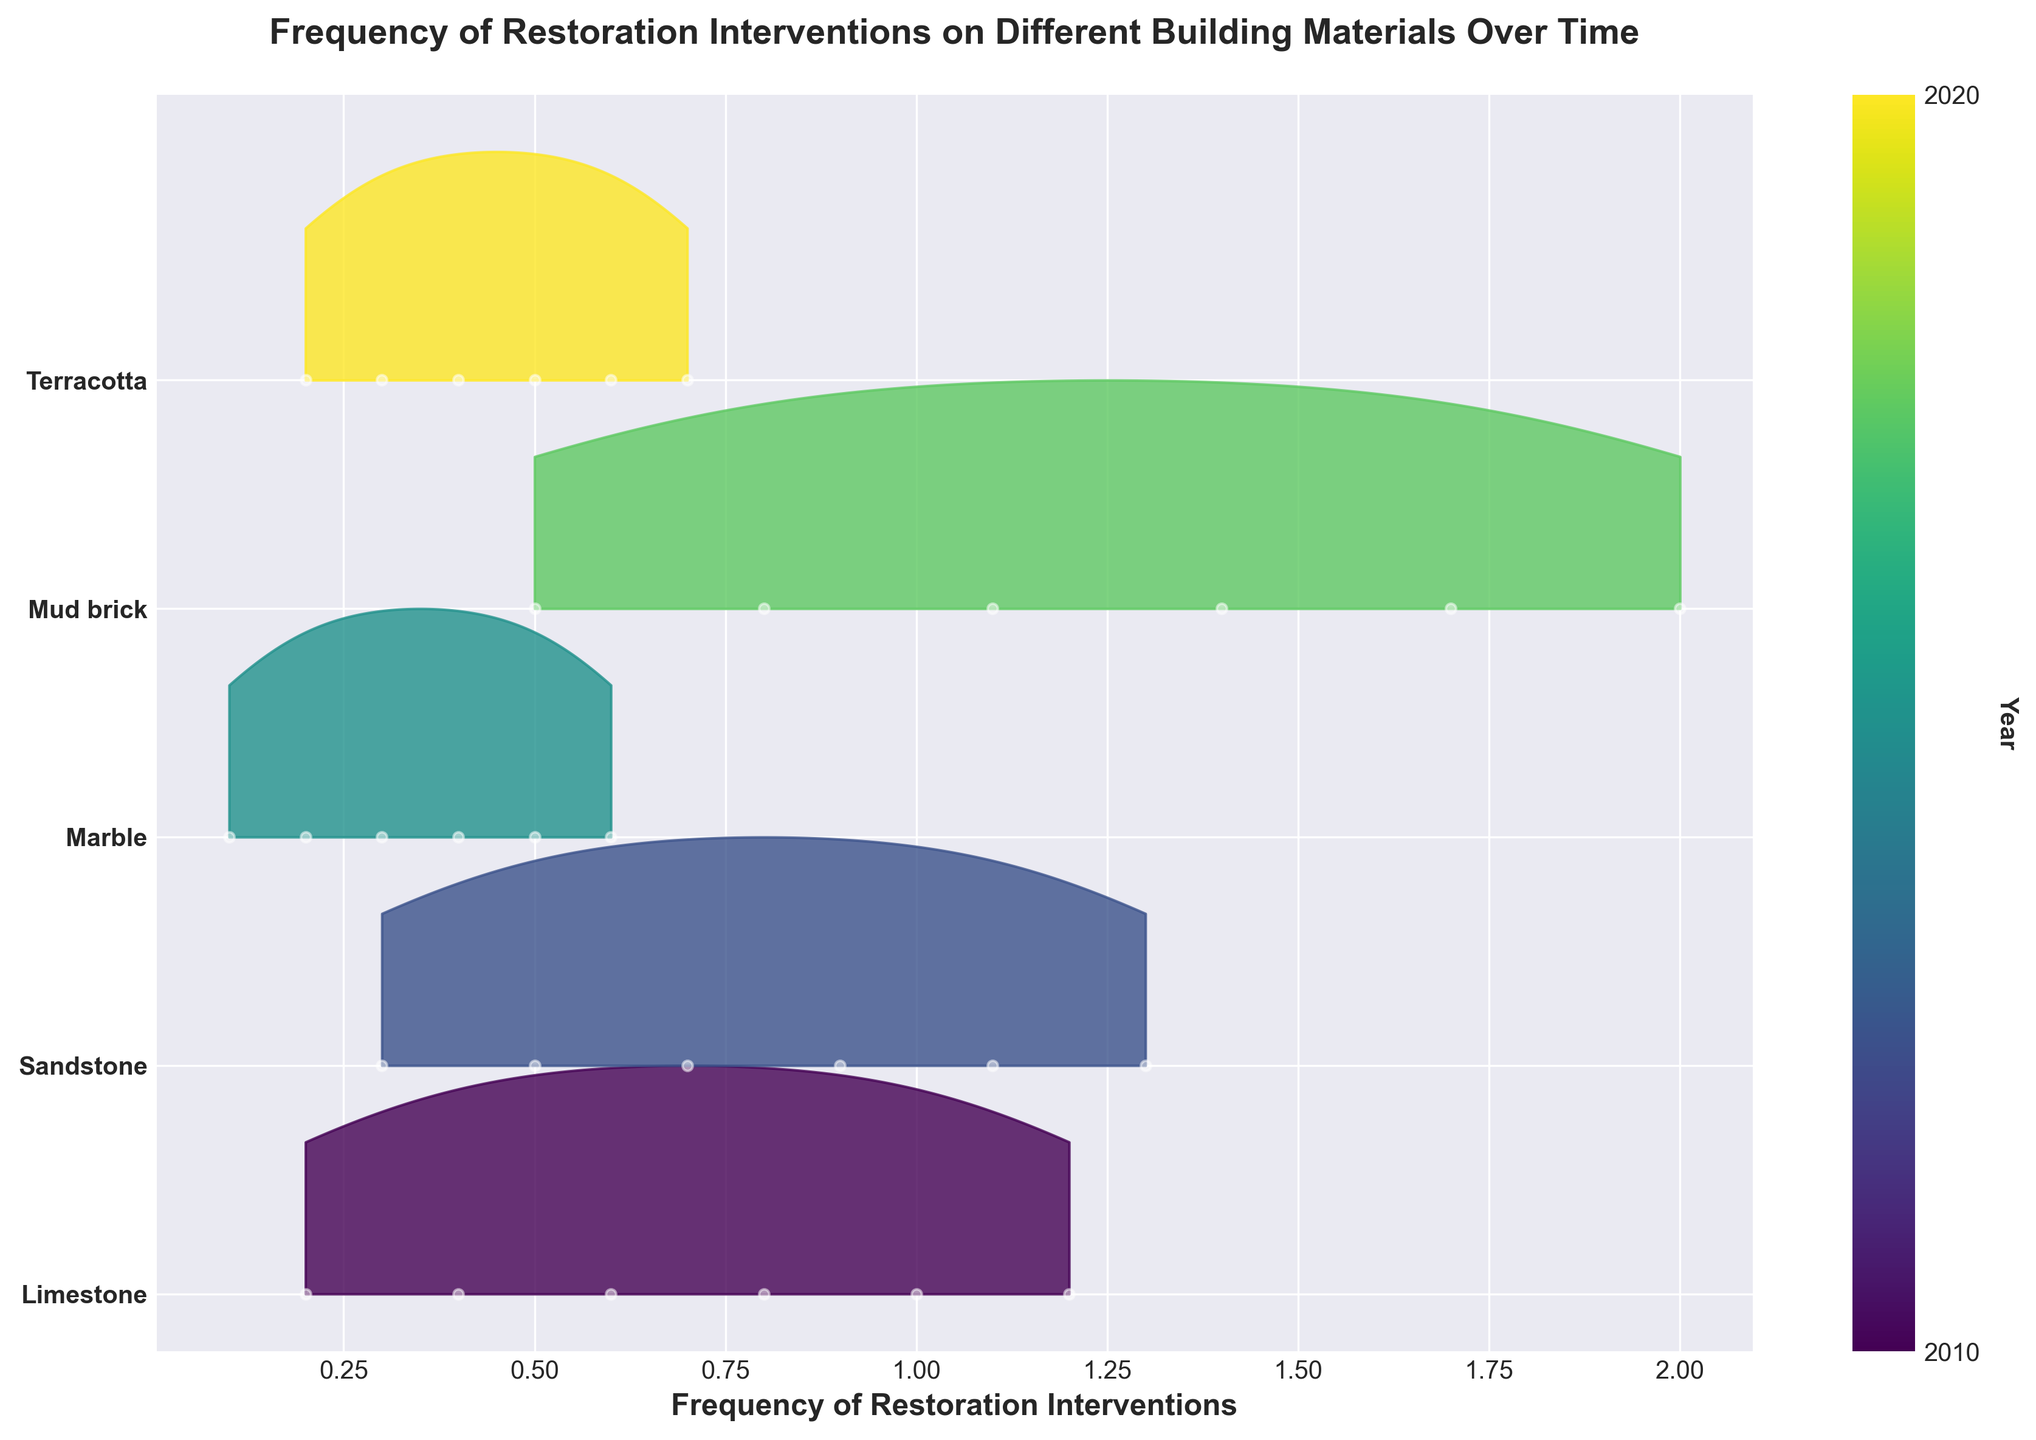What is the title of the plot? The title is typically located at the top of the plot. It is bold and provides the main subject of the plot.
Answer: Frequency of Restoration Interventions on Different Building Materials Over Time How many different materials are shown in the plot? The y-axis shows the different materials. Counting the unique labels on the y-axis gives the total number of different materials.
Answer: Five Which material had the highest frequency of restoration interventions in 2020? Look along the x-axis for the year 2020 and identify which material's plot reaches the highest frequency value.
Answer: Mud brick Which material required the least restoration intervention frequency overall? Look at the range of frequencies for each material and identify the one with the lowest maximum frequency.
Answer: Marble How does the frequency of restoration interventions for Limestone in 2016 compare to 2010? Locate the points for Limestone in 2010 and 2016 and compare their frequency values on the x-axis.
Answer: Higher in 2016 What is the average frequency of restoration interventions for Sandstone over the years? Add the frequency values for Sandstone and divide by the number of years (data points). (0.3 + 0.5 + 0.7 + 0.9 + 1.1 + 1.3)/6 = 0.8
Answer: 0.8 Which material shows the largest increase in intervention frequency from 2010 to 2020? For each material, subtract the 2010 frequency from the 2020 frequency and find the material with the largest difference.
Answer: Mud brick Compare the frequency of restoration interventions for Marble and Terracotta in 2014. Which is higher? Identify the frequencies for Marble and Terracotta in 2014 and compare them.
Answer: Terracotta What trend can be observed in the frequency of restoration interventions for Mud brick over the years? Look at the points for Mud brick from 2010 to 2020 and describe the overall direction of change.
Answer: Steadily increasing Which year had the highest restoration frequency for all materials combined? Sum the frequencies for all materials for each year and identify the year with the highest sum. (sum for 2020 is highest: 1.2 + 1.3 + 0.6 + 2.0 + 0.7 = 5.8)
Answer: 2020 